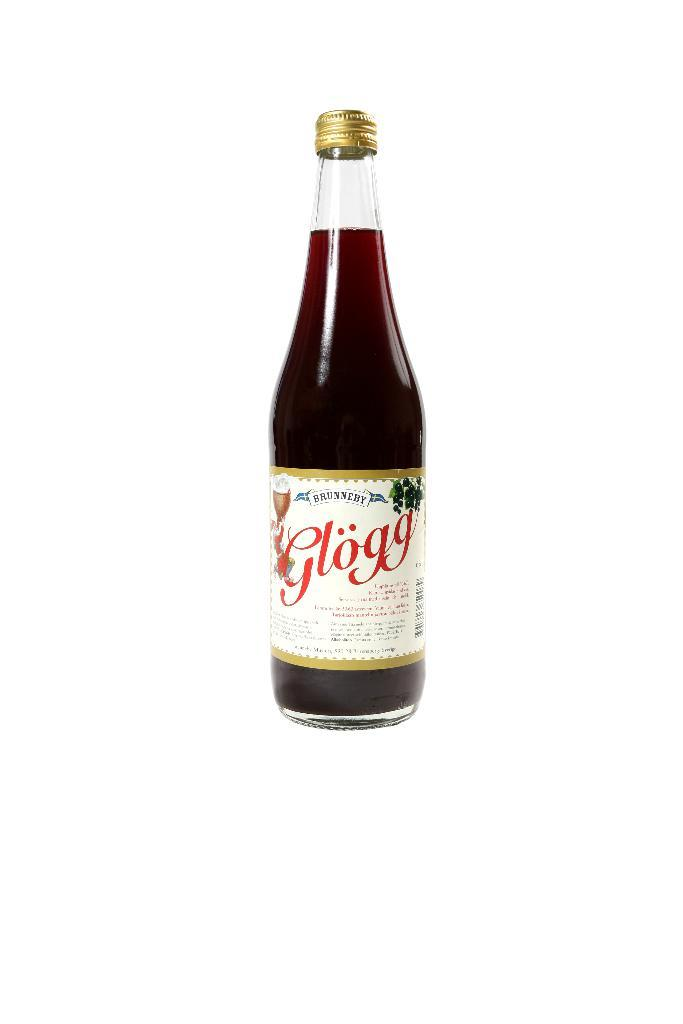<image>
Summarize the visual content of the image. Bottle of Glogg with a white label in front of a white background. 